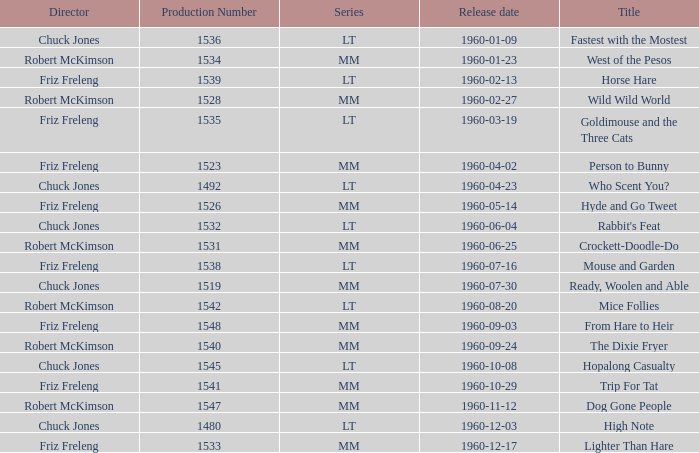What is the production number of From Hare to Heir? 1548.0. Write the full table. {'header': ['Director', 'Production Number', 'Series', 'Release date', 'Title'], 'rows': [['Chuck Jones', '1536', 'LT', '1960-01-09', 'Fastest with the Mostest'], ['Robert McKimson', '1534', 'MM', '1960-01-23', 'West of the Pesos'], ['Friz Freleng', '1539', 'LT', '1960-02-13', 'Horse Hare'], ['Robert McKimson', '1528', 'MM', '1960-02-27', 'Wild Wild World'], ['Friz Freleng', '1535', 'LT', '1960-03-19', 'Goldimouse and the Three Cats'], ['Friz Freleng', '1523', 'MM', '1960-04-02', 'Person to Bunny'], ['Chuck Jones', '1492', 'LT', '1960-04-23', 'Who Scent You?'], ['Friz Freleng', '1526', 'MM', '1960-05-14', 'Hyde and Go Tweet'], ['Chuck Jones', '1532', 'LT', '1960-06-04', "Rabbit's Feat"], ['Robert McKimson', '1531', 'MM', '1960-06-25', 'Crockett-Doodle-Do'], ['Friz Freleng', '1538', 'LT', '1960-07-16', 'Mouse and Garden'], ['Chuck Jones', '1519', 'MM', '1960-07-30', 'Ready, Woolen and Able'], ['Robert McKimson', '1542', 'LT', '1960-08-20', 'Mice Follies'], ['Friz Freleng', '1548', 'MM', '1960-09-03', 'From Hare to Heir'], ['Robert McKimson', '1540', 'MM', '1960-09-24', 'The Dixie Fryer'], ['Chuck Jones', '1545', 'LT', '1960-10-08', 'Hopalong Casualty'], ['Friz Freleng', '1541', 'MM', '1960-10-29', 'Trip For Tat'], ['Robert McKimson', '1547', 'MM', '1960-11-12', 'Dog Gone People'], ['Chuck Jones', '1480', 'LT', '1960-12-03', 'High Note'], ['Friz Freleng', '1533', 'MM', '1960-12-17', 'Lighter Than Hare']]} 